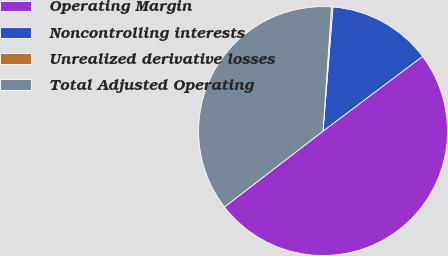Convert chart. <chart><loc_0><loc_0><loc_500><loc_500><pie_chart><fcel>Operating Margin<fcel>Noncontrolling interests<fcel>Unrealized derivative losses<fcel>Total Adjusted Operating<nl><fcel>49.81%<fcel>13.48%<fcel>0.19%<fcel>36.52%<nl></chart> 